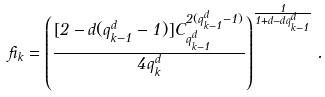<formula> <loc_0><loc_0><loc_500><loc_500>\beta _ { k } = \left ( \frac { [ 2 - d ( q ^ { d } _ { k - 1 } - 1 ) ] C _ { q ^ { d } _ { k - 1 } } ^ { 2 ( q ^ { d } _ { k - 1 } - 1 ) } } { 4 q ^ { d } _ { k } } \right ) ^ { \frac { 1 } { 1 + d - d q ^ { d } _ { k - 1 } } } .</formula> 